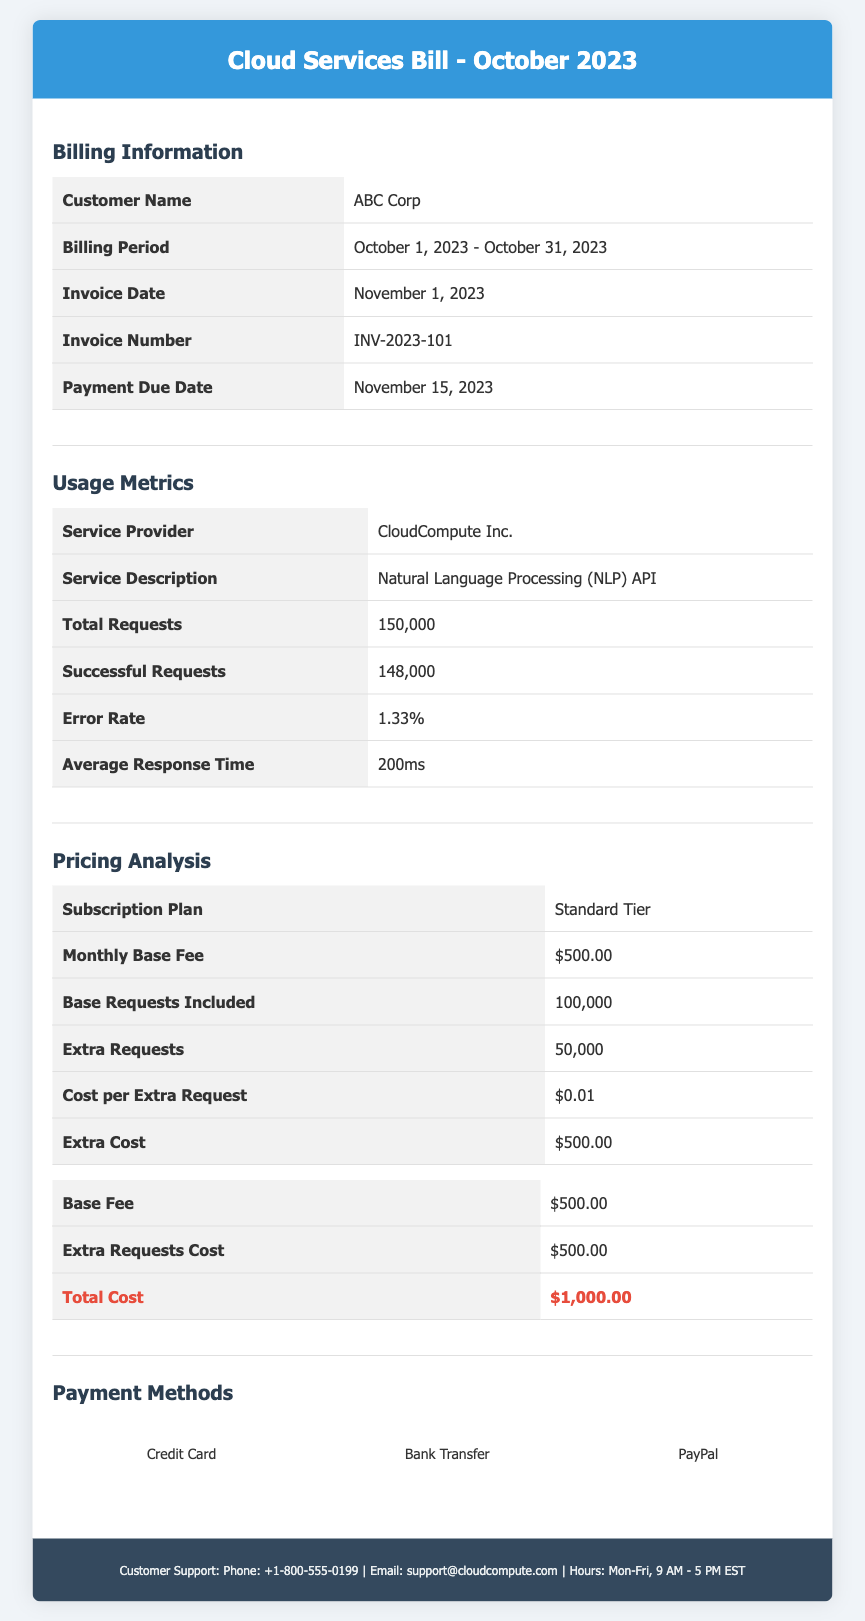what is the customer name? The customer name is listed in the billing information section of the document.
Answer: ABC Corp what is the total cost? The total cost can be found in the pricing analysis section under the total cost table.
Answer: $1,000.00 what is the number of successful requests? The number of successful requests is detailed in the usage metrics section of the document.
Answer: 148,000 what is the error rate? The error rate is provided in the usage metrics table, which indicates the performance of the service.
Answer: 1.33% what is the payment due date? The payment due date can be found in the billing information section of the document.
Answer: November 15, 2023 how many extra requests were made? The extra requests are calculated based on the total requests and the base requests included in the subscription plan.
Answer: 50,000 what is the monthly base fee? The monthly base fee is specified in the pricing analysis section of the document.
Answer: $500.00 what subscription plan is used? The subscription plan is mentioned in the pricing analysis section among the pricing details.
Answer: Standard Tier what is the cost per extra request? The cost per extra request is outlined in the pricing analysis section, detailing additional charges.
Answer: $0.01 